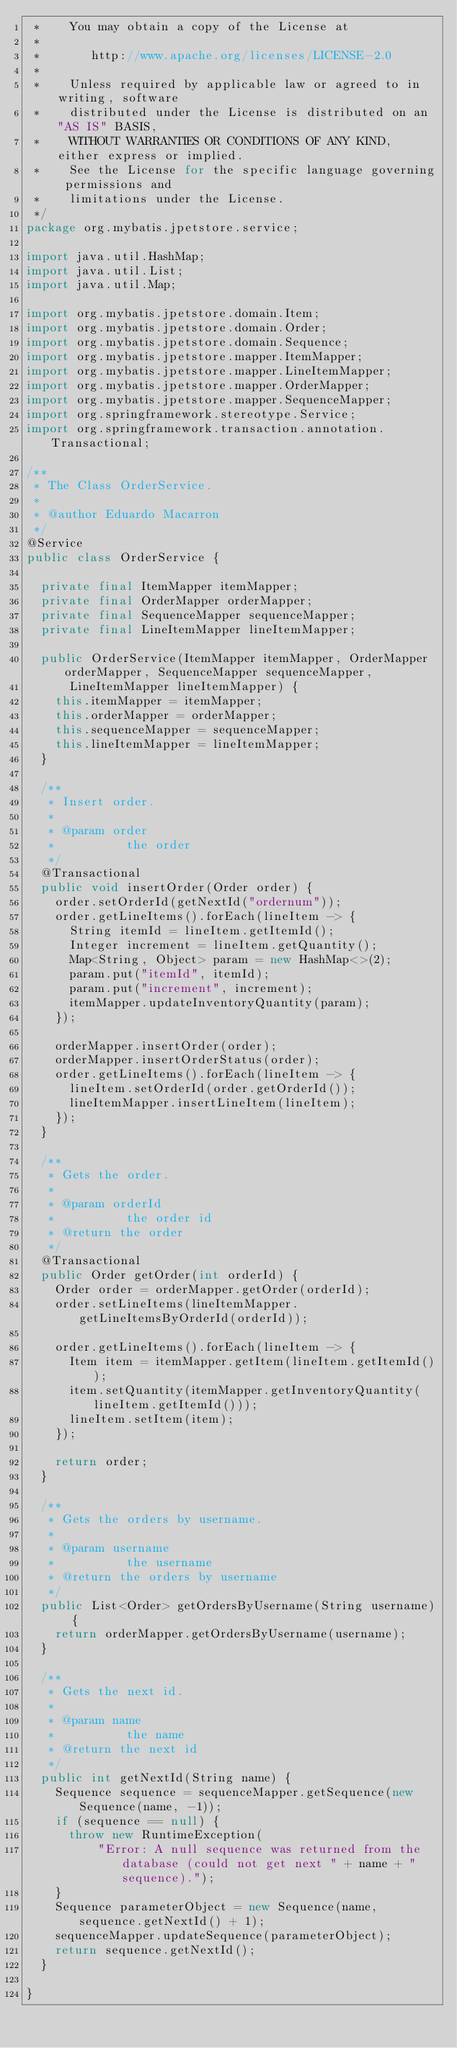Convert code to text. <code><loc_0><loc_0><loc_500><loc_500><_Java_> *    You may obtain a copy of the License at
 *
 *       http://www.apache.org/licenses/LICENSE-2.0
 *
 *    Unless required by applicable law or agreed to in writing, software
 *    distributed under the License is distributed on an "AS IS" BASIS,
 *    WITHOUT WARRANTIES OR CONDITIONS OF ANY KIND, either express or implied.
 *    See the License for the specific language governing permissions and
 *    limitations under the License.
 */
package org.mybatis.jpetstore.service;

import java.util.HashMap;
import java.util.List;
import java.util.Map;

import org.mybatis.jpetstore.domain.Item;
import org.mybatis.jpetstore.domain.Order;
import org.mybatis.jpetstore.domain.Sequence;
import org.mybatis.jpetstore.mapper.ItemMapper;
import org.mybatis.jpetstore.mapper.LineItemMapper;
import org.mybatis.jpetstore.mapper.OrderMapper;
import org.mybatis.jpetstore.mapper.SequenceMapper;
import org.springframework.stereotype.Service;
import org.springframework.transaction.annotation.Transactional;

/**
 * The Class OrderService.
 *
 * @author Eduardo Macarron
 */
@Service
public class OrderService {

  private final ItemMapper itemMapper;
  private final OrderMapper orderMapper;
  private final SequenceMapper sequenceMapper;
  private final LineItemMapper lineItemMapper;

  public OrderService(ItemMapper itemMapper, OrderMapper orderMapper, SequenceMapper sequenceMapper,
      LineItemMapper lineItemMapper) {
    this.itemMapper = itemMapper;
    this.orderMapper = orderMapper;
    this.sequenceMapper = sequenceMapper;
    this.lineItemMapper = lineItemMapper;
  }

  /**
   * Insert order.
   *
   * @param order
   *          the order
   */
  @Transactional
  public void insertOrder(Order order) {
    order.setOrderId(getNextId("ordernum"));
    order.getLineItems().forEach(lineItem -> {
      String itemId = lineItem.getItemId();
      Integer increment = lineItem.getQuantity();
      Map<String, Object> param = new HashMap<>(2);
      param.put("itemId", itemId);
      param.put("increment", increment);
      itemMapper.updateInventoryQuantity(param);
    });

    orderMapper.insertOrder(order);
    orderMapper.insertOrderStatus(order);
    order.getLineItems().forEach(lineItem -> {
      lineItem.setOrderId(order.getOrderId());
      lineItemMapper.insertLineItem(lineItem);
    });
  }

  /**
   * Gets the order.
   *
   * @param orderId
   *          the order id
   * @return the order
   */
  @Transactional
  public Order getOrder(int orderId) {
    Order order = orderMapper.getOrder(orderId);
    order.setLineItems(lineItemMapper.getLineItemsByOrderId(orderId));

    order.getLineItems().forEach(lineItem -> {
      Item item = itemMapper.getItem(lineItem.getItemId());
      item.setQuantity(itemMapper.getInventoryQuantity(lineItem.getItemId()));
      lineItem.setItem(item);
    });

    return order;
  }

  /**
   * Gets the orders by username.
   *
   * @param username
   *          the username
   * @return the orders by username
   */
  public List<Order> getOrdersByUsername(String username) {
    return orderMapper.getOrdersByUsername(username);
  }

  /**
   * Gets the next id.
   *
   * @param name
   *          the name
   * @return the next id
   */
  public int getNextId(String name) {
    Sequence sequence = sequenceMapper.getSequence(new Sequence(name, -1));
    if (sequence == null) {
      throw new RuntimeException(
          "Error: A null sequence was returned from the database (could not get next " + name + " sequence).");
    }
    Sequence parameterObject = new Sequence(name, sequence.getNextId() + 1);
    sequenceMapper.updateSequence(parameterObject);
    return sequence.getNextId();
  }

}
</code> 